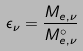Convert formula to latex. <formula><loc_0><loc_0><loc_500><loc_500>\epsilon _ { \nu } = \frac { M _ { e , \nu } } { M _ { e , \nu } ^ { \circ } }</formula> 